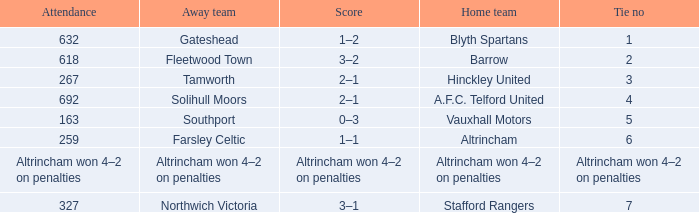What was the score when there were 7 ties? 3–1. 